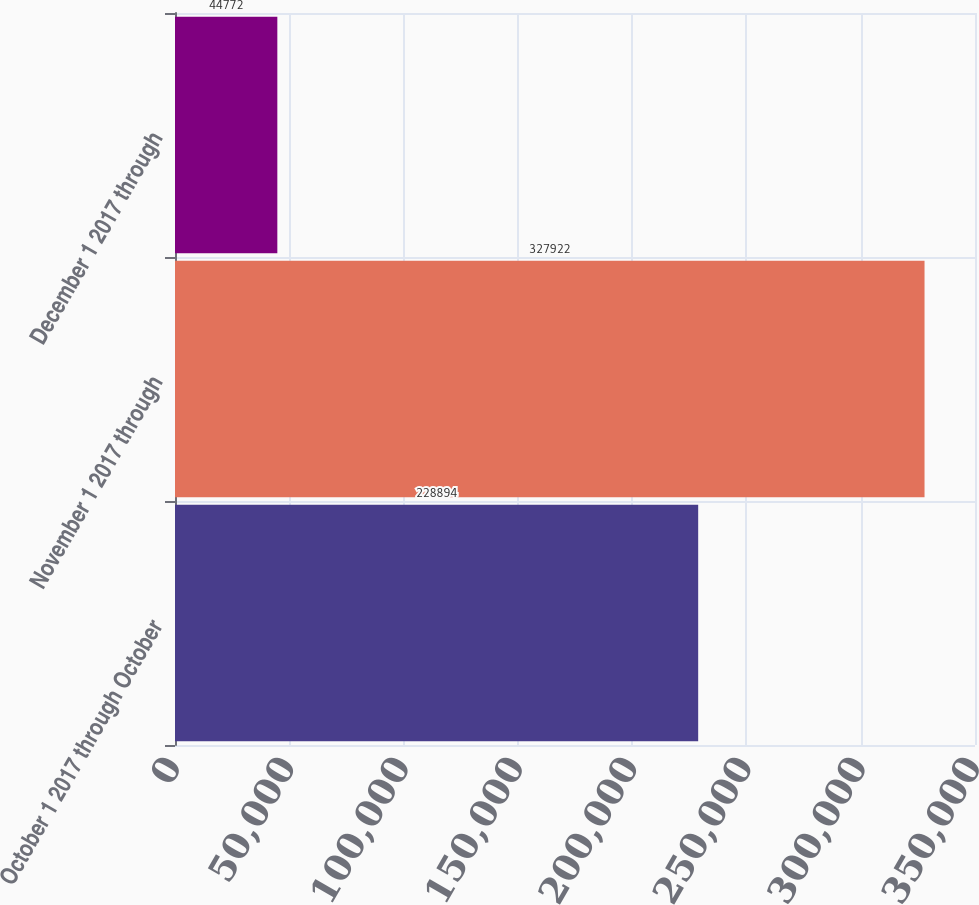<chart> <loc_0><loc_0><loc_500><loc_500><bar_chart><fcel>October 1 2017 through October<fcel>November 1 2017 through<fcel>December 1 2017 through<nl><fcel>228894<fcel>327922<fcel>44772<nl></chart> 